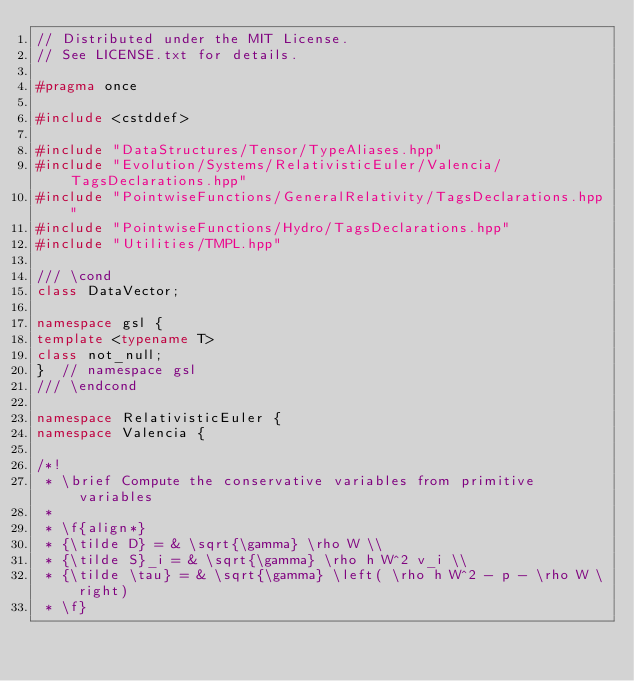<code> <loc_0><loc_0><loc_500><loc_500><_C++_>// Distributed under the MIT License.
// See LICENSE.txt for details.

#pragma once

#include <cstddef>

#include "DataStructures/Tensor/TypeAliases.hpp"
#include "Evolution/Systems/RelativisticEuler/Valencia/TagsDeclarations.hpp"
#include "PointwiseFunctions/GeneralRelativity/TagsDeclarations.hpp"
#include "PointwiseFunctions/Hydro/TagsDeclarations.hpp"
#include "Utilities/TMPL.hpp"

/// \cond
class DataVector;

namespace gsl {
template <typename T>
class not_null;
}  // namespace gsl
/// \endcond

namespace RelativisticEuler {
namespace Valencia {

/*!
 * \brief Compute the conservative variables from primitive variables
 *
 * \f{align*}
 * {\tilde D} = & \sqrt{\gamma} \rho W \\
 * {\tilde S}_i = & \sqrt{\gamma} \rho h W^2 v_i \\
 * {\tilde \tau} = & \sqrt{\gamma} \left( \rho h W^2 - p - \rho W \right)
 * \f}</code> 